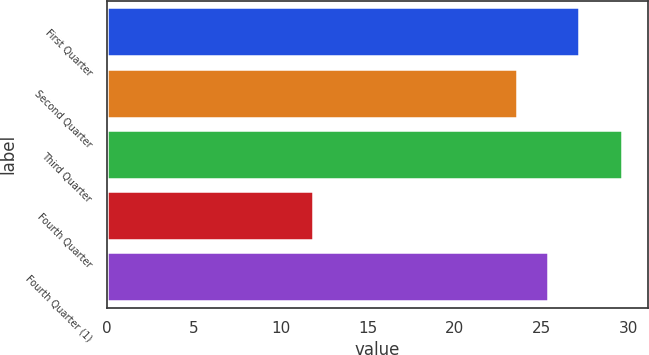Convert chart. <chart><loc_0><loc_0><loc_500><loc_500><bar_chart><fcel>First Quarter<fcel>Second Quarter<fcel>Third Quarter<fcel>Fourth Quarter<fcel>Fourth Quarter (1)<nl><fcel>27.13<fcel>23.57<fcel>29.64<fcel>11.88<fcel>25.35<nl></chart> 